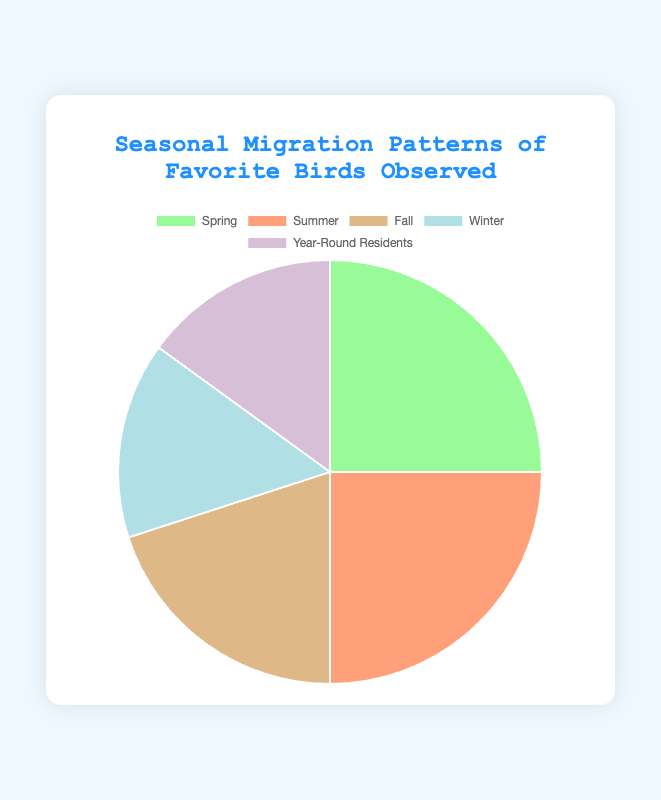What season has the least number of birds observed? The color representing Winter covers the smallest section of the pie chart, indicating it has the least number of birds observed.
Answer: Winter How many more birds are observed in Spring and Summer compared to Fall and Winter combined? First, add the values for Spring and Summer (25 + 25 = 50). Then, add the values for Fall and Winter (20 + 15 = 35). Finally, subtract the number observed in Fall and Winter from the number in Spring and Summer (50 - 35 = 15).
Answer: 15 Which seasons have an equal number of birds observed? Observing the pie chart, Spring and Summer sections are equal in size.
Answer: Spring and Summer What is the total percentage of birds observed during the seasons that have less than 20 birds each? The sections smaller than 20 are Winter (15) and Year-Round Residents (15). Summing these values gives 30 birds. Calculate the percentage by dividing 30 by the total number of birds (100) and then multiplying by 100 to get the percentage (30 / 100 * 100 = 30%).
Answer: 30% What is the ratio of birds observed in Spring to those observed in Fall? From the pie chart, the number of birds observed in Spring is 25 and in Fall is 20. The ratio is 25:20 or simplified, 5:4.
Answer: 5:4 Which two seasons together account for half of the birds observed? Identify two sections whose sum equals 50% of the pie chart. The values 25 (Spring) and 25 (Summer) together account for 50% of the total.
Answer: Spring and Summer How much larger is the number of birds observed in Summer compared to Year-Round Residents? The number of birds observed in Summer is 25, and for Year-Round Residents, it is 15. Subtracting these values gives 25 - 15 = 10.
Answer: 10 What fraction of the birds are observed in Fall? The number of birds observed in Fall is 20 out of a total of 100. The fraction is 20/100, simplified to 1/5.
Answer: 1/5 If you combined the birds observed in Winter and Year-Round Residents, how would their combined total compare to those observed in Summer? Add Winter (15) and Year-Round Residents (15) gives a total of 30. Comparing this with Summer's 25, the combined total is 5 more than Summer.
Answer: 5 more What percentage of the birds are observed in the seasons other than Spring? First, sum the number of birds for all seasons other than Spring: Summer (25) + Fall (20) + Winter (15) + Year-Round Residents (15) = 75. The total number of birds observed is 100. The percentage is (75/100) * 100 = 75%.
Answer: 75% 